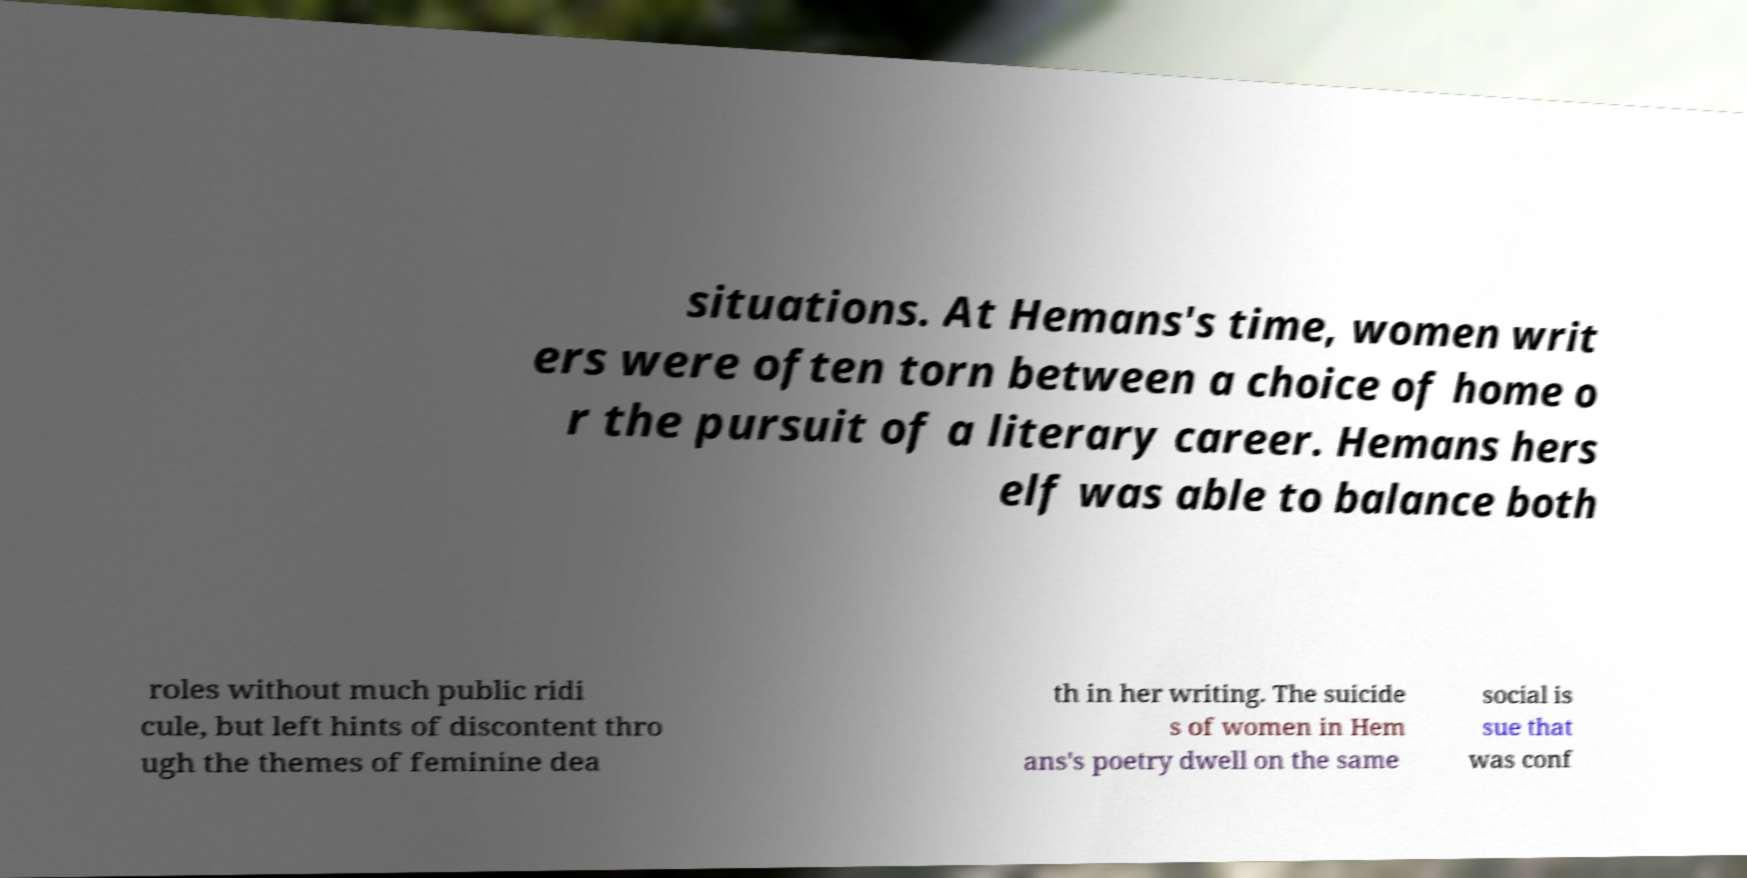Can you accurately transcribe the text from the provided image for me? situations. At Hemans's time, women writ ers were often torn between a choice of home o r the pursuit of a literary career. Hemans hers elf was able to balance both roles without much public ridi cule, but left hints of discontent thro ugh the themes of feminine dea th in her writing. The suicide s of women in Hem ans's poetry dwell on the same social is sue that was conf 